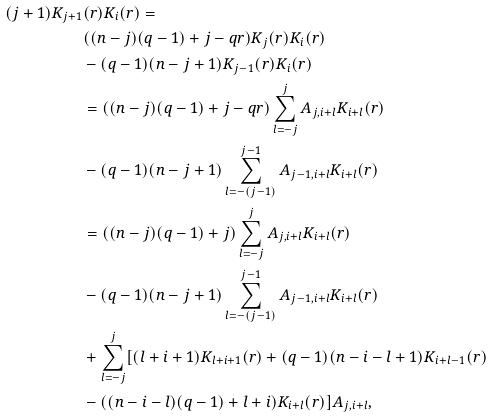<formula> <loc_0><loc_0><loc_500><loc_500>( j + 1 ) K _ { j + 1 } & ( r ) K _ { i } ( r ) = \\ & ( ( n - j ) ( q - 1 ) + j - q r ) K _ { j } ( r ) K _ { i } ( r ) \\ & - ( q - 1 ) ( n - j + 1 ) K _ { j - 1 } ( r ) K _ { i } ( r ) \\ & = \left ( ( n - j ) ( q - 1 ) + j - q r \right ) \sum _ { l = - j } ^ { j } A _ { j , i + l } K _ { i + l } ( r ) \\ & - ( q - 1 ) ( n - j + 1 ) \sum _ { l = - ( j - 1 ) } ^ { j - 1 } A _ { j - 1 , i + l } K _ { i + l } ( r ) \\ & = \left ( ( n - j ) ( q - 1 ) + j \right ) \sum _ { l = - j } ^ { j } A _ { j , i + l } K _ { i + l } ( r ) \\ & - ( q - 1 ) ( n - j + 1 ) \sum _ { l = - ( j - 1 ) } ^ { j - 1 } A _ { j - 1 , i + l } K _ { i + l } ( r ) \\ & + \sum _ { l = - j } ^ { j } [ ( l + i + 1 ) K _ { l + i + 1 } ( r ) + ( q - 1 ) ( n - i - l + 1 ) K _ { i + l - 1 } ( r ) \\ & - ( ( n - i - l ) ( q - 1 ) + l + i ) K _ { i + l } ( r ) ] A _ { j , i + l } ,</formula> 